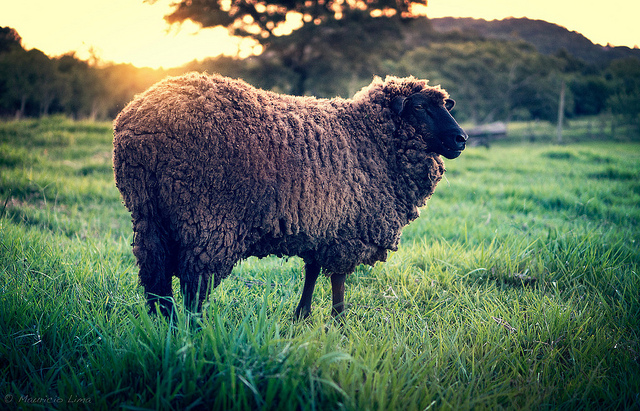How might the surrounding landscape change throughout the year? Throughout the year, the landscape surrounding the sheep will undergo a beautiful transformation. In spring, the field will burst into life with vibrant green grass and wildflowers, attracting bees and butterflies. Summer will bring longer days with the sun casting a warm, golden glow over the landscape, and the grass will grow tall and lush. As autumn arrives, the trees in the distance will don a tapestry of red, orange, and yellow leaves, while the grass will begin to fade to a subdued green. Finally, winter will cloak the field in a frosty blanket, and the trees may stand bare against the cold, clear sky. Each season paints the landscape with its own palette, providing a dynamic and ever-changing view.  How does the lighting change the mood of the image? The warm, golden lighting creates a serene and peaceful mood in the image. It highlights the sheep, casting long, soft shadows that add a tranquil and almost magical quality to the scene. The light seems to wrap everything in a gentle embrace, making the field feel welcoming and full of life. 